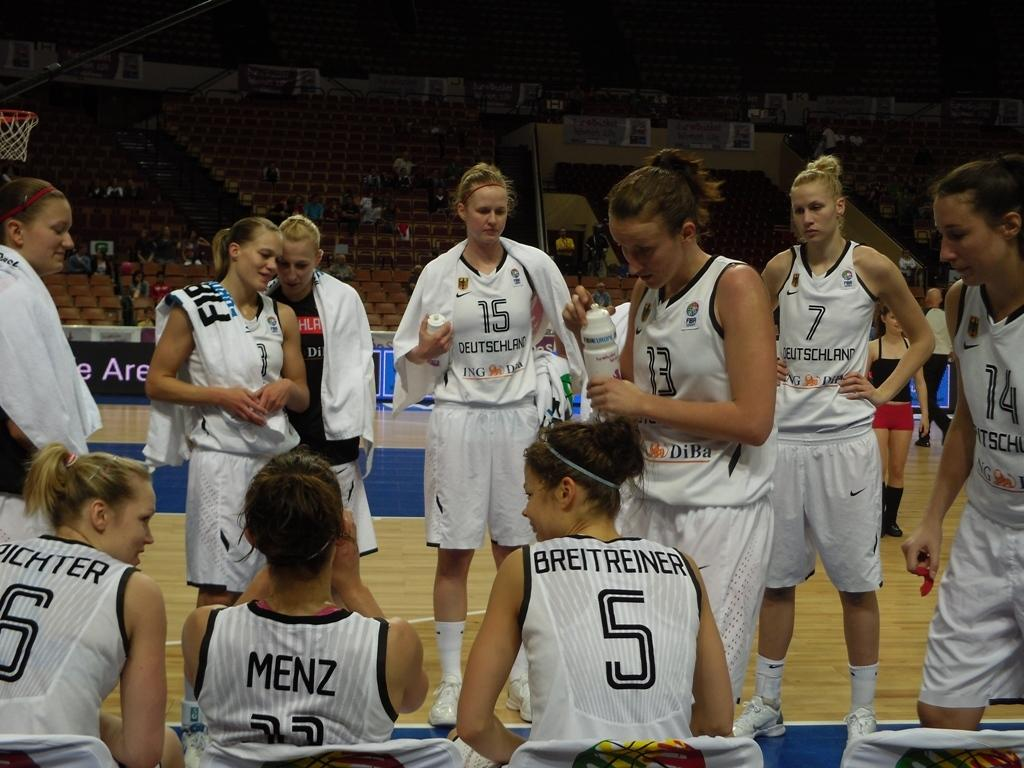Provide a one-sentence caption for the provided image. A woman's basketball team on the court from Deutschland. 